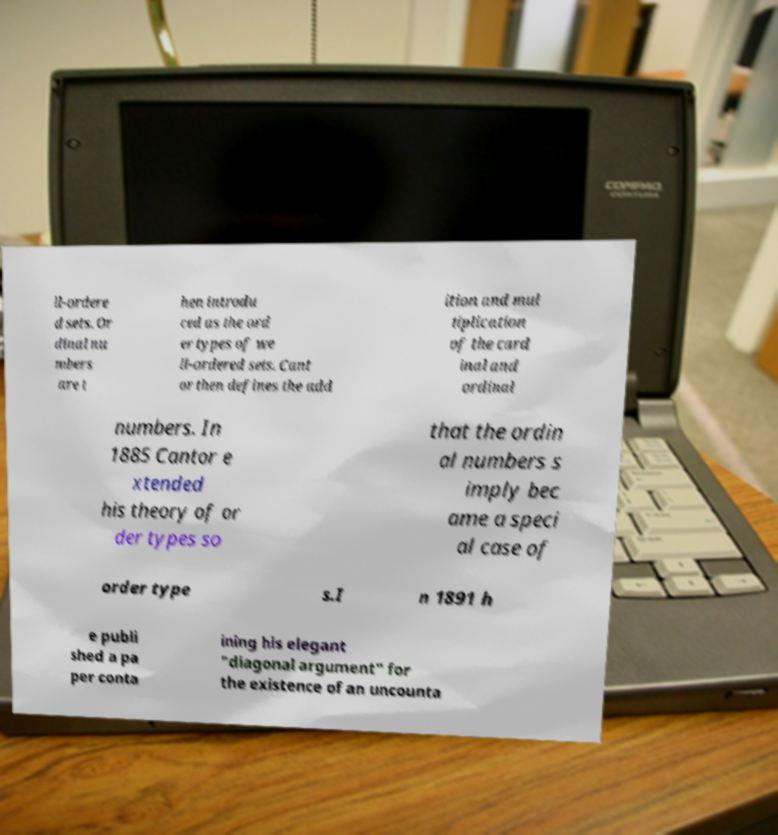Please read and relay the text visible in this image. What does it say? ll-ordere d sets. Or dinal nu mbers are t hen introdu ced as the ord er types of we ll-ordered sets. Cant or then defines the add ition and mul tiplication of the card inal and ordinal numbers. In 1885 Cantor e xtended his theory of or der types so that the ordin al numbers s imply bec ame a speci al case of order type s.I n 1891 h e publi shed a pa per conta ining his elegant "diagonal argument" for the existence of an uncounta 